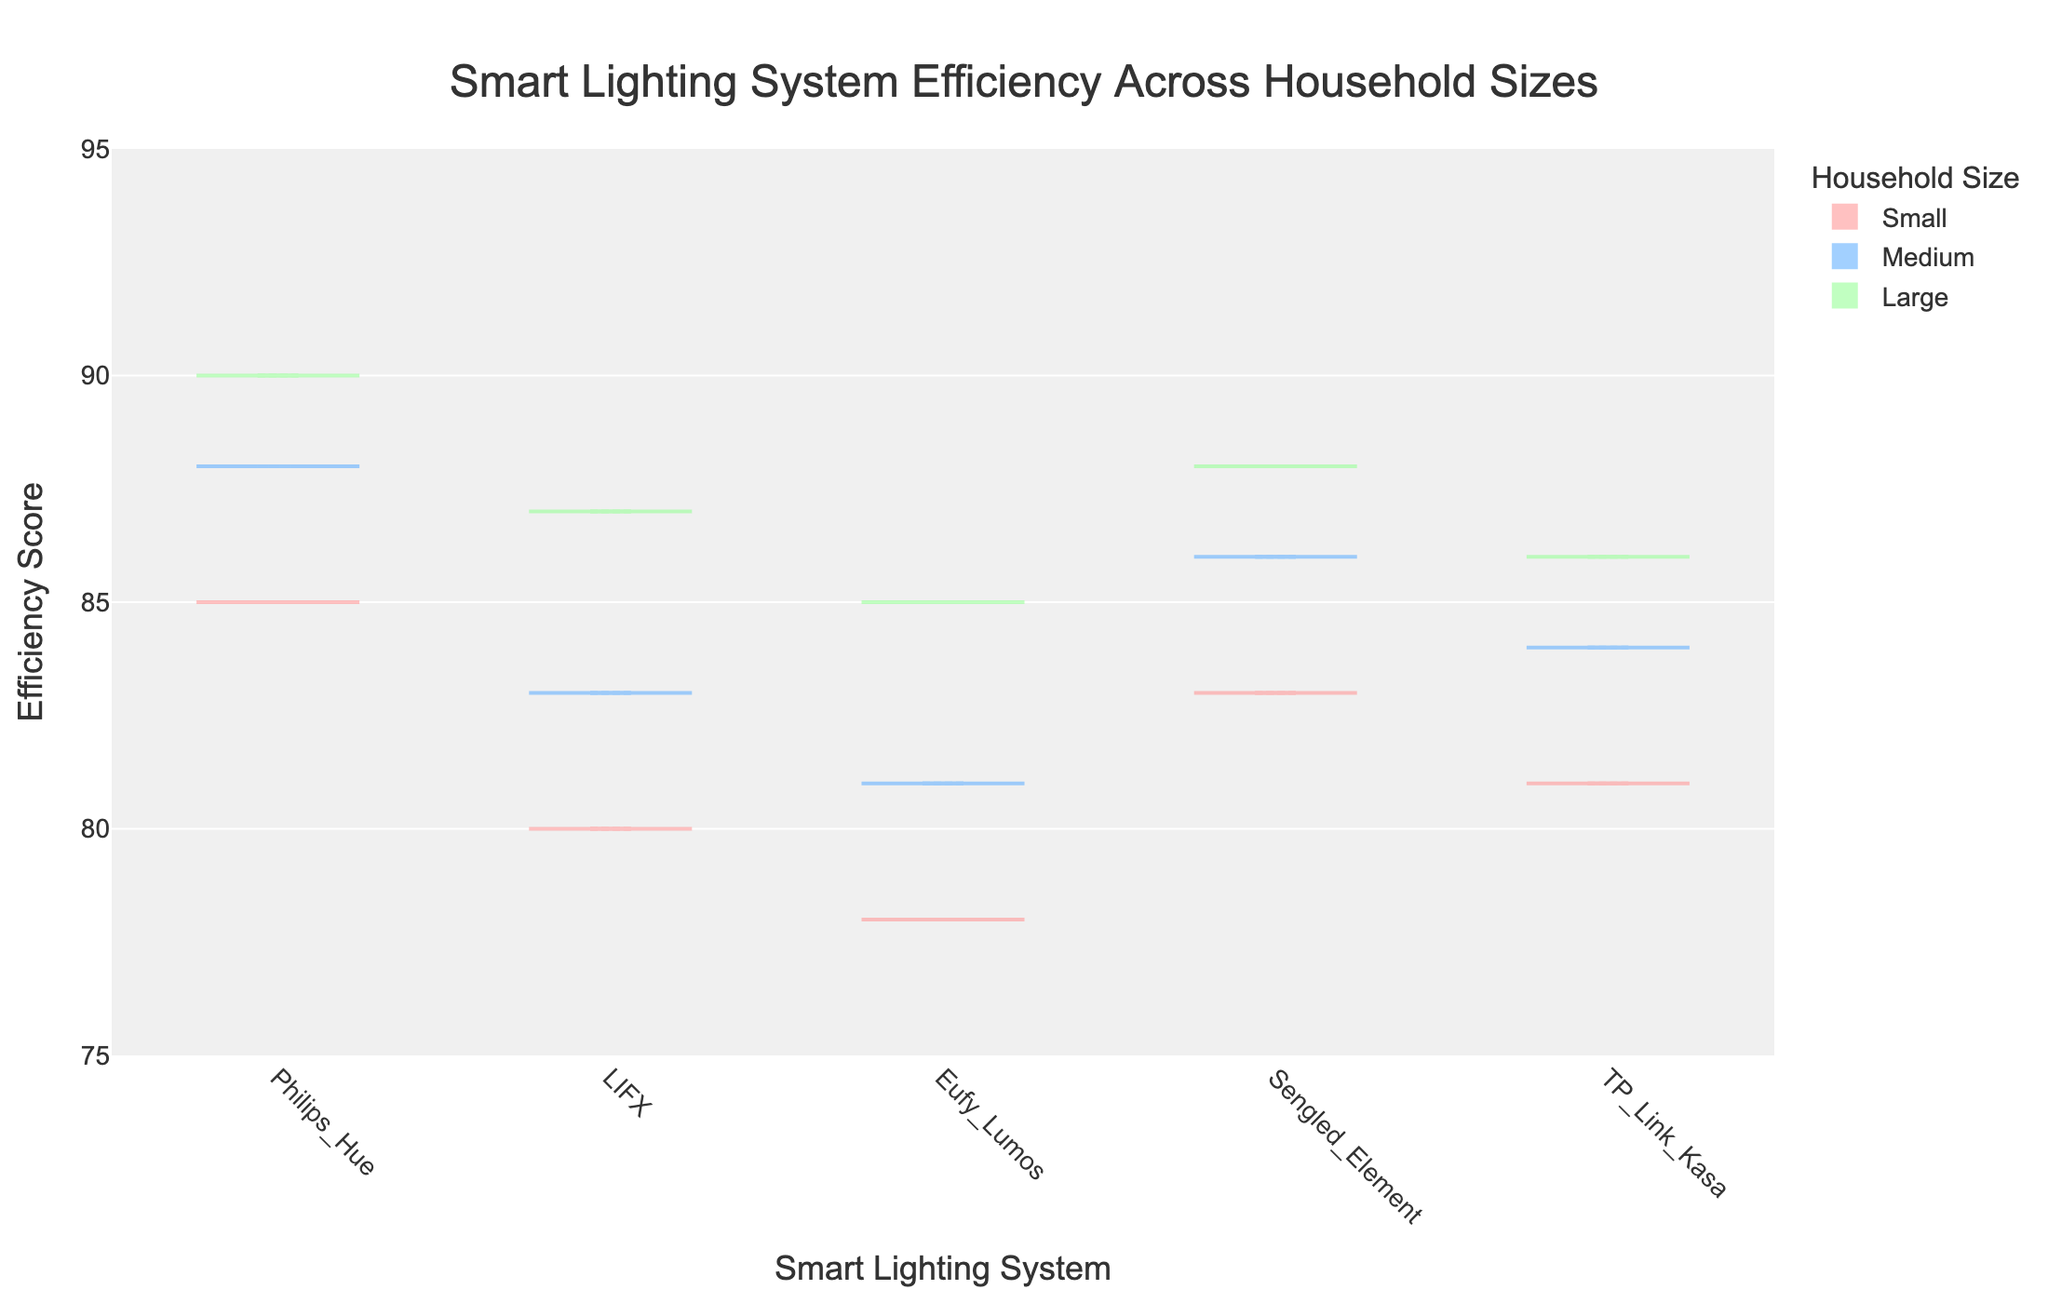What is the title of the figure? The title of the figure can be found at the top center. It describes the overall theme of the plot.
Answer: "Smart Lighting System Efficiency Across Household Sizes" What are the labels of the x-axis and y-axis? The x-axis label is below the x-axis, indicating what the horizontal dimension represents, and the y-axis label is next to the y-axis, indicating what the vertical dimension represents.
Answer: "Smart Lighting System" (x-axis) and "Efficiency Score" (y-axis) Which smart lighting system has the highest efficiency score in large households? To determine this, look at the 'Large' household size section of the violin plots and find the one with the highest point. This can be observed in the 'Large' section's maximum value.
Answer: Philips Hue What is the range of efficiency scores displayed in the plot? The range can be determined by observing the y-axis limits. These are the minimum and maximum efficiency values shown in the plot.
Answer: 75 to 95 Which household size category has the lowest median efficiency score? For each household size, examine the box in the violin plots that represents the median value (line inside the box). Identify which category's median line is lowest.
Answer: Small How does the distribution of efficiency scores for the 'Eufy Lumos' system compare between small and large households? Observe the shape of the violin plots and the spread of data points for 'Eufy Lumos' in both 'Small' and 'Large' household sizes. Notice differences in spread, central values, and extremities.
Answer: Larger households have higher efficiency and less variability What is the interquartile range (IQR) of the efficiency scores for the 'TP-Link Kasa' system in medium households? The IQR is calculated by finding the difference between the upper quartile (75th percentile) and the lower quartile (25th percentile) in the box plot section of the violin plot for medium households.
Answer: 84 - 83 = 1 Which smart lighting system shows the least variability in efficiency scores across all household sizes? Variability can be assessed by looking at the width of the violin plots. The narrower the plot, the less variability. Compare the widths across all systems and household sizes.
Answer: Philips Hue Does the 'Sengled Element' have a higher average efficiency in small households than 'LIFX' in medium households? To determine this, find the average for 'Sengled Element' in 'Small' households and 'LIFX' in 'Medium' households by looking at the data points' central tendency. Compare the averages.
Answer: No, they are very close but 'LIFX' in medium households is slightly higher Which household size shows the highest overall efficiency scores across different systems? Inspect the violin plots for all household sizes and compare their highest efficiency score points. Identify the household size with the most consistently higher scores.
Answer: Large 